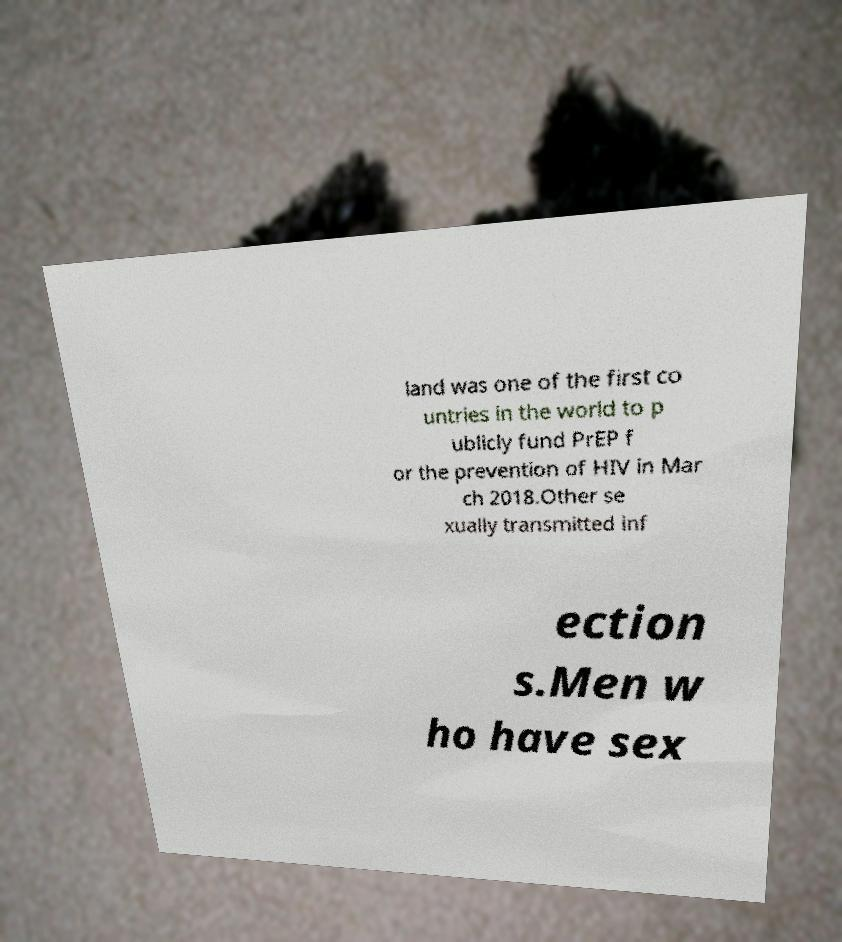Can you accurately transcribe the text from the provided image for me? land was one of the first co untries in the world to p ublicly fund PrEP f or the prevention of HIV in Mar ch 2018.Other se xually transmitted inf ection s.Men w ho have sex 